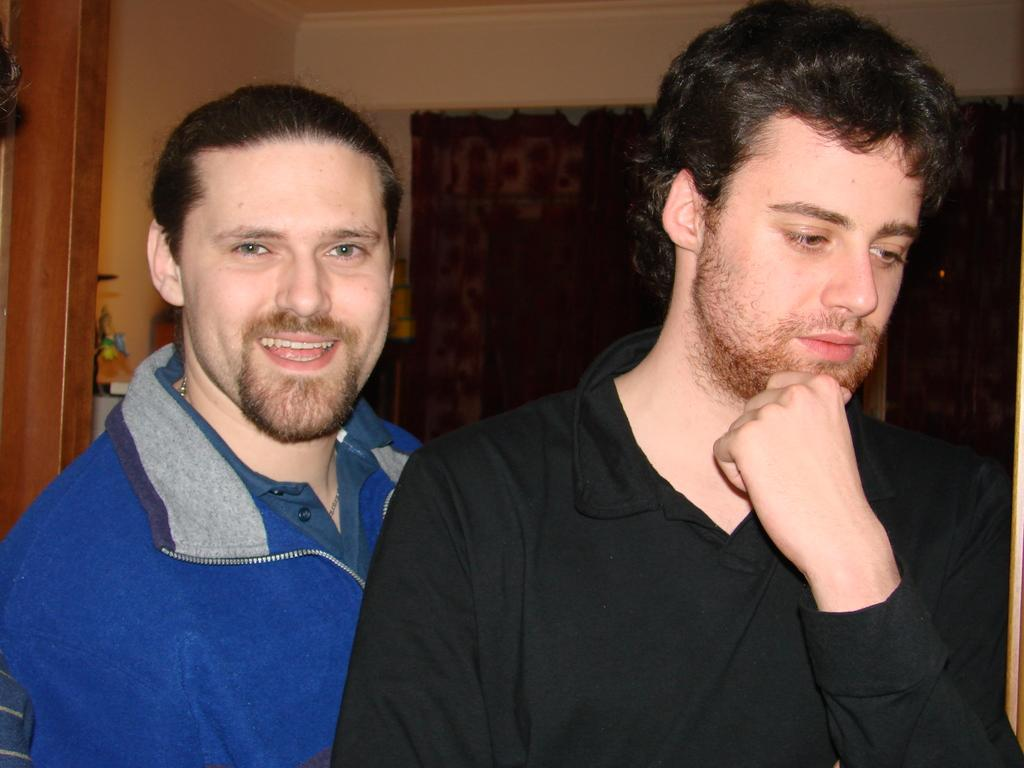How many people are present in the image? There are two people in the image. What can be seen in the background of the image? There is a wall in the background of the image. What type of wine is the friend holding in the image? There is no wine or friend present in the image; it features two people and a wall in the background. 